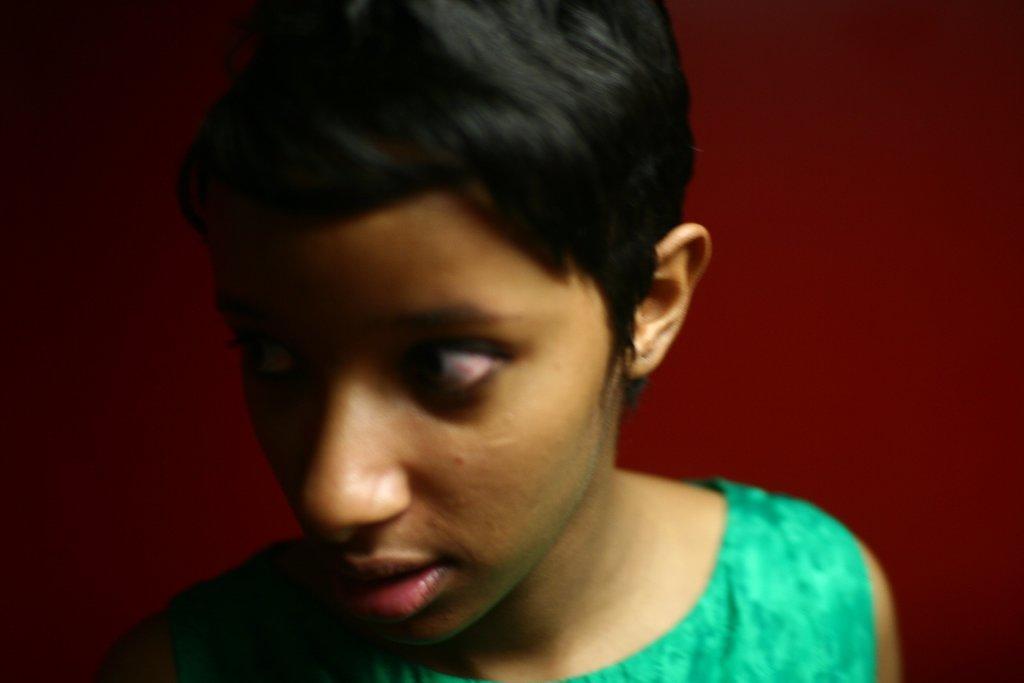How would you summarize this image in a sentence or two? This image consists of a person and wall. This image is taken may be in a room. 